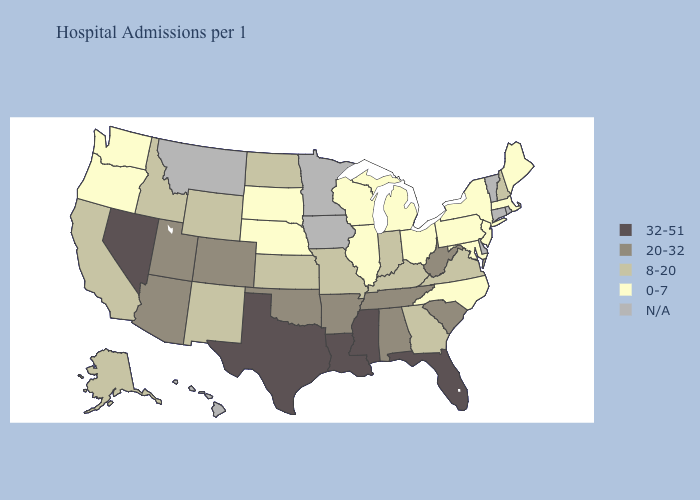Does Mississippi have the highest value in the South?
Quick response, please. Yes. Does Oregon have the lowest value in the West?
Write a very short answer. Yes. What is the lowest value in states that border Montana?
Give a very brief answer. 0-7. What is the value of Minnesota?
Short answer required. N/A. What is the value of Idaho?
Answer briefly. 8-20. What is the value of South Dakota?
Answer briefly. 0-7. What is the lowest value in the USA?
Keep it brief. 0-7. What is the value of New Mexico?
Short answer required. 8-20. What is the lowest value in the Northeast?
Keep it brief. 0-7. What is the lowest value in the MidWest?
Be succinct. 0-7. Name the states that have a value in the range 8-20?
Be succinct. Alaska, California, Georgia, Idaho, Indiana, Kansas, Kentucky, Missouri, New Hampshire, New Mexico, North Dakota, Virginia, Wyoming. Does the map have missing data?
Short answer required. Yes. How many symbols are there in the legend?
Answer briefly. 5. Name the states that have a value in the range 20-32?
Concise answer only. Alabama, Arizona, Arkansas, Colorado, Oklahoma, South Carolina, Tennessee, Utah, West Virginia. 